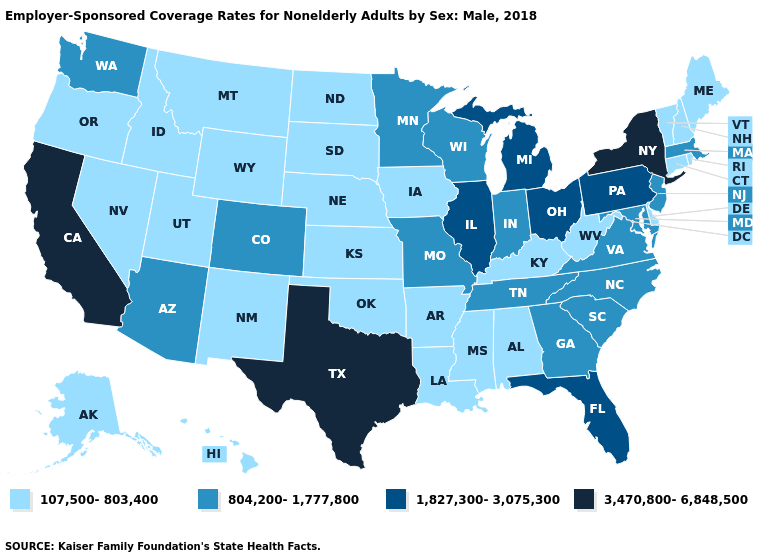Name the states that have a value in the range 804,200-1,777,800?
Write a very short answer. Arizona, Colorado, Georgia, Indiana, Maryland, Massachusetts, Minnesota, Missouri, New Jersey, North Carolina, South Carolina, Tennessee, Virginia, Washington, Wisconsin. What is the value of Utah?
Give a very brief answer. 107,500-803,400. Name the states that have a value in the range 804,200-1,777,800?
Write a very short answer. Arizona, Colorado, Georgia, Indiana, Maryland, Massachusetts, Minnesota, Missouri, New Jersey, North Carolina, South Carolina, Tennessee, Virginia, Washington, Wisconsin. What is the highest value in the USA?
Keep it brief. 3,470,800-6,848,500. Does the first symbol in the legend represent the smallest category?
Keep it brief. Yes. What is the value of South Carolina?
Write a very short answer. 804,200-1,777,800. Does Idaho have a lower value than Minnesota?
Short answer required. Yes. Name the states that have a value in the range 107,500-803,400?
Quick response, please. Alabama, Alaska, Arkansas, Connecticut, Delaware, Hawaii, Idaho, Iowa, Kansas, Kentucky, Louisiana, Maine, Mississippi, Montana, Nebraska, Nevada, New Hampshire, New Mexico, North Dakota, Oklahoma, Oregon, Rhode Island, South Dakota, Utah, Vermont, West Virginia, Wyoming. Name the states that have a value in the range 1,827,300-3,075,300?
Concise answer only. Florida, Illinois, Michigan, Ohio, Pennsylvania. Name the states that have a value in the range 3,470,800-6,848,500?
Be succinct. California, New York, Texas. What is the value of Ohio?
Be succinct. 1,827,300-3,075,300. What is the value of Alabama?
Short answer required. 107,500-803,400. Does New Mexico have the same value as New York?
Be succinct. No. What is the highest value in states that border Idaho?
Quick response, please. 804,200-1,777,800. What is the highest value in the USA?
Answer briefly. 3,470,800-6,848,500. 